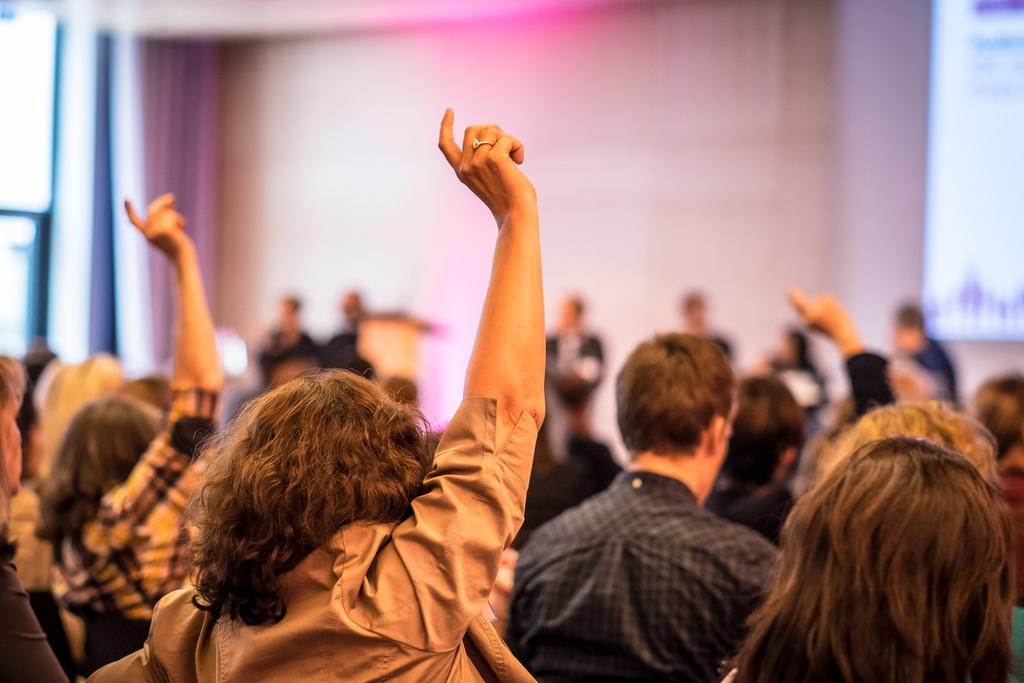What are the people in the image doing while seated on chairs? Some people are raising their hands in the image. What else can be seen in the image besides people seated on chairs? There are people standing in the image, as well as a podium and a projector screen. What type of seed is being used to tie a knot on the podium in the image? There is no seed or knot present on the podium in the image. What sound does the alarm make in the image? There is no alarm present in the image. 